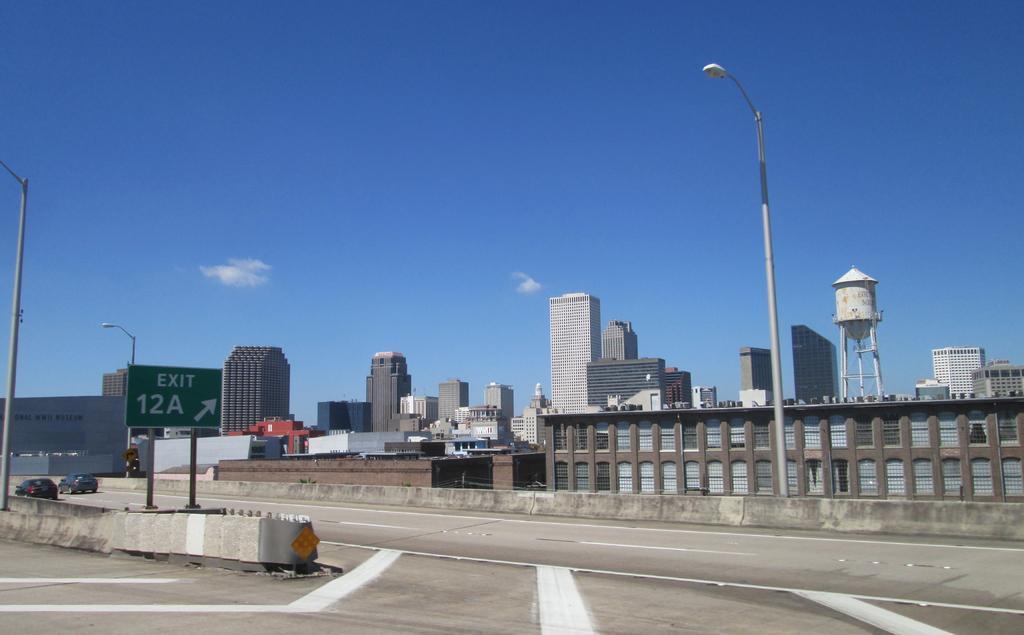Could you give a brief overview of what you see in this image? In this picture there are buildings and street lights and there is a board on the pole and there is text on the board and there are vehicles on the road. At the top there is sky and there are clouds. At the bottom there is a road. 